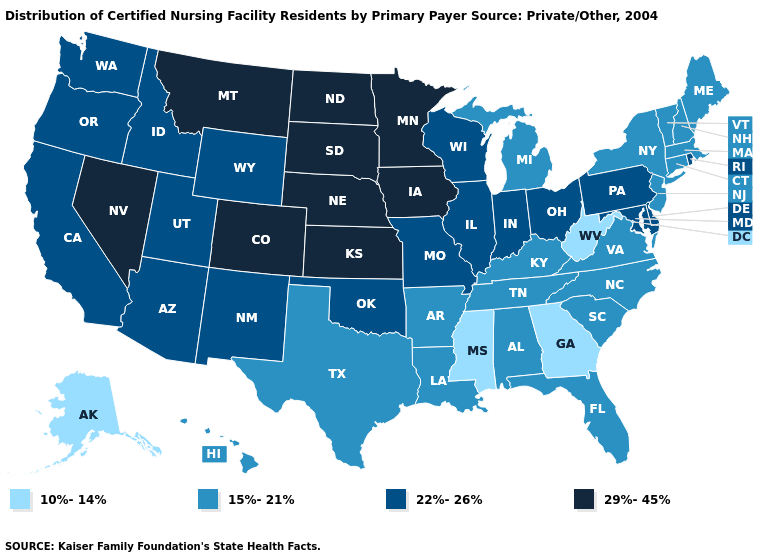What is the value of South Dakota?
Concise answer only. 29%-45%. Does Alaska have the lowest value in the West?
Be succinct. Yes. What is the lowest value in states that border Missouri?
Short answer required. 15%-21%. What is the value of North Carolina?
Short answer required. 15%-21%. What is the value of Rhode Island?
Give a very brief answer. 22%-26%. What is the value of Kentucky?
Answer briefly. 15%-21%. Which states have the lowest value in the USA?
Give a very brief answer. Alaska, Georgia, Mississippi, West Virginia. Among the states that border Colorado , does Kansas have the lowest value?
Keep it brief. No. What is the value of New Mexico?
Give a very brief answer. 22%-26%. What is the value of Georgia?
Write a very short answer. 10%-14%. What is the value of New Hampshire?
Answer briefly. 15%-21%. What is the value of Ohio?
Concise answer only. 22%-26%. Does Idaho have the lowest value in the USA?
Concise answer only. No. Name the states that have a value in the range 10%-14%?
Be succinct. Alaska, Georgia, Mississippi, West Virginia. 